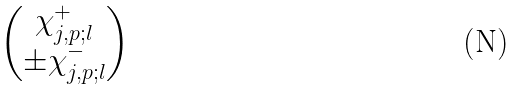<formula> <loc_0><loc_0><loc_500><loc_500>\begin{pmatrix} \chi ^ { + } _ { j , p ; l } \\ \pm \chi ^ { - } _ { j , p ; l } \end{pmatrix}</formula> 